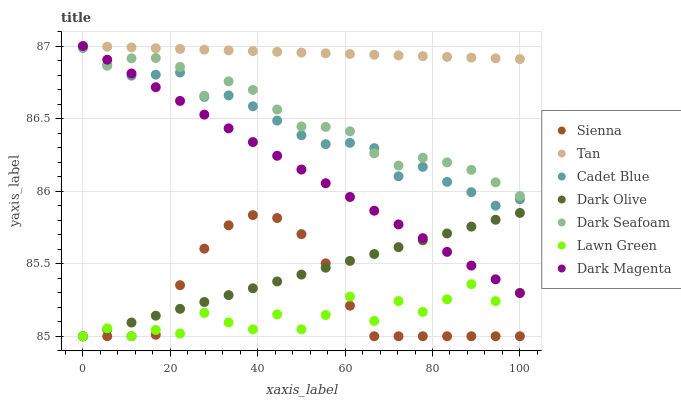Does Lawn Green have the minimum area under the curve?
Answer yes or no. Yes. Does Tan have the maximum area under the curve?
Answer yes or no. Yes. Does Cadet Blue have the minimum area under the curve?
Answer yes or no. No. Does Cadet Blue have the maximum area under the curve?
Answer yes or no. No. Is Tan the smoothest?
Answer yes or no. Yes. Is Lawn Green the roughest?
Answer yes or no. Yes. Is Cadet Blue the smoothest?
Answer yes or no. No. Is Cadet Blue the roughest?
Answer yes or no. No. Does Lawn Green have the lowest value?
Answer yes or no. Yes. Does Cadet Blue have the lowest value?
Answer yes or no. No. Does Tan have the highest value?
Answer yes or no. Yes. Does Cadet Blue have the highest value?
Answer yes or no. No. Is Sienna less than Dark Magenta?
Answer yes or no. Yes. Is Cadet Blue greater than Sienna?
Answer yes or no. Yes. Does Dark Magenta intersect Dark Olive?
Answer yes or no. Yes. Is Dark Magenta less than Dark Olive?
Answer yes or no. No. Is Dark Magenta greater than Dark Olive?
Answer yes or no. No. Does Sienna intersect Dark Magenta?
Answer yes or no. No. 